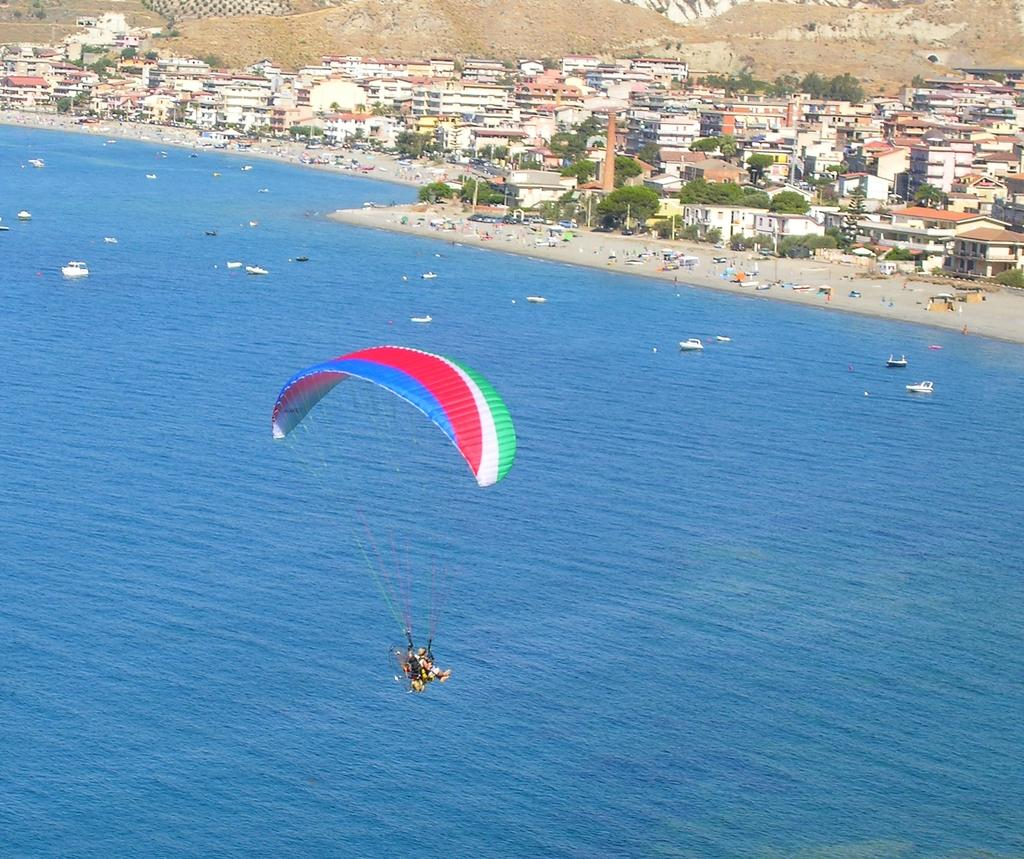What activity are the two people in the image engaged in? The two people in the image are paragliding. What can be seen in the water body in the image? There is a group of boats in the water body. What is the location of the people on the seashore? The people on the seashore are located near the water body. What type of vegetation is visible in the image? Trees are visible in the image. What type of structures are present in the image? Buildings are present in the image. What type of geographical feature is visible in the image? Hills are visible in the image. How many cups of pollution can be seen in the image? There is no pollution or cups present in the image. Are there any bats visible in the image? There are no bats present in the image. 